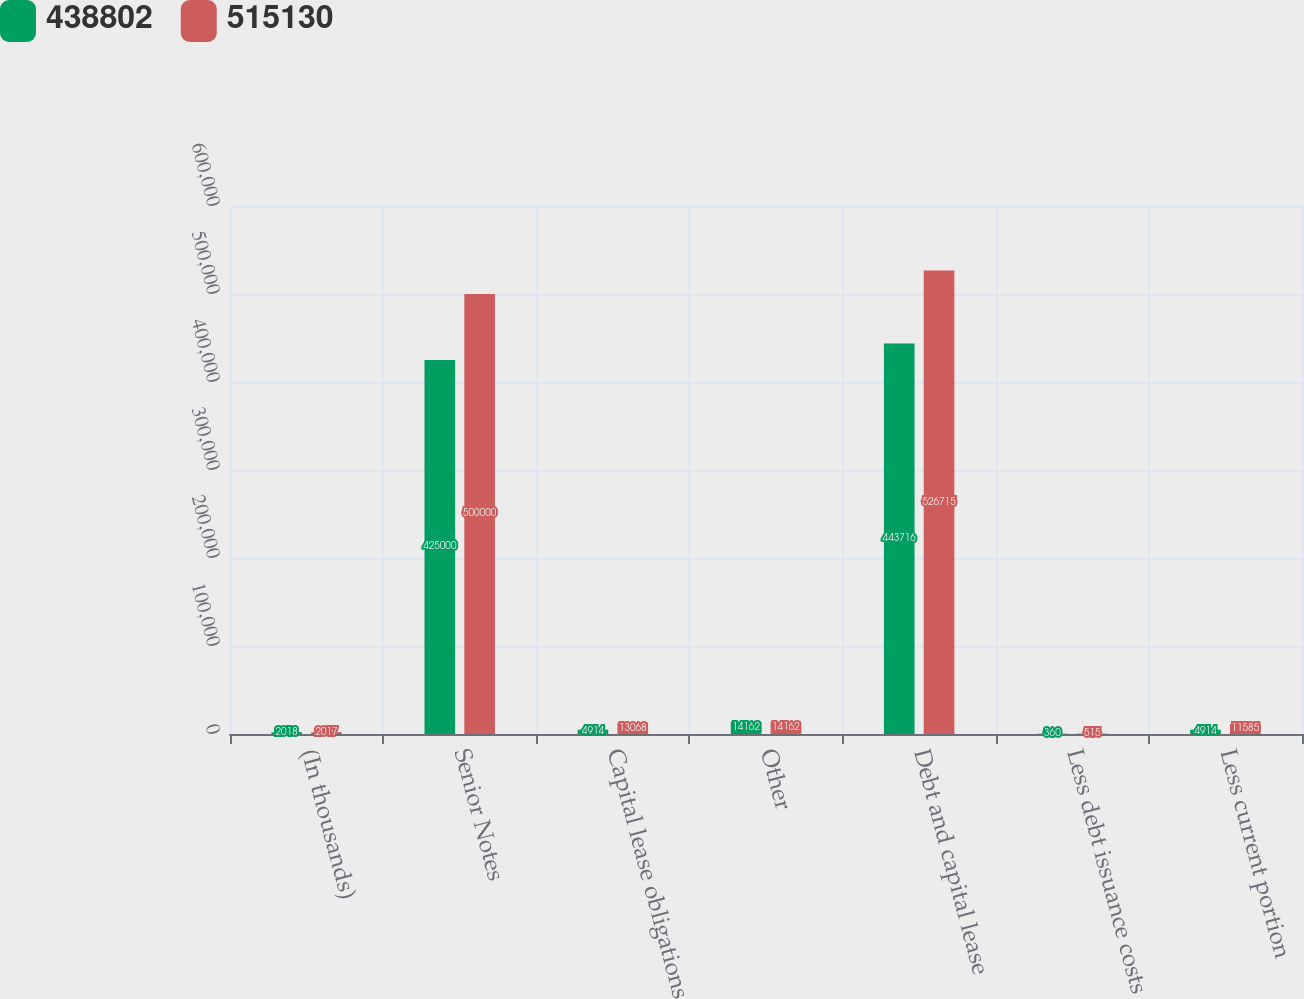Convert chart to OTSL. <chart><loc_0><loc_0><loc_500><loc_500><stacked_bar_chart><ecel><fcel>(In thousands)<fcel>Senior Notes<fcel>Capital lease obligations<fcel>Other<fcel>Debt and capital lease<fcel>Less debt issuance costs<fcel>Less current portion<nl><fcel>438802<fcel>2018<fcel>425000<fcel>4914<fcel>14162<fcel>443716<fcel>360<fcel>4914<nl><fcel>515130<fcel>2017<fcel>500000<fcel>13068<fcel>14162<fcel>526715<fcel>515<fcel>11585<nl></chart> 